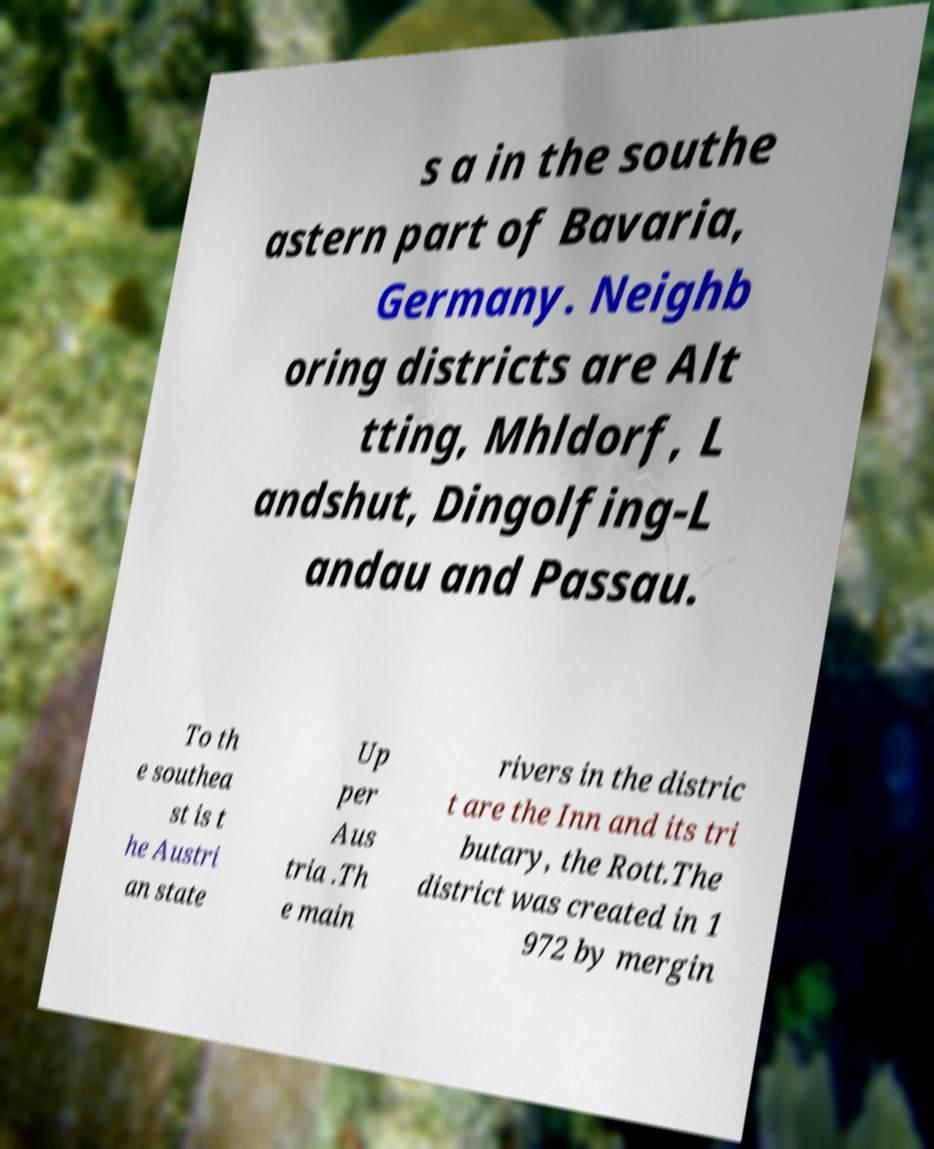Could you assist in decoding the text presented in this image and type it out clearly? s a in the southe astern part of Bavaria, Germany. Neighb oring districts are Alt tting, Mhldorf, L andshut, Dingolfing-L andau and Passau. To th e southea st is t he Austri an state Up per Aus tria .Th e main rivers in the distric t are the Inn and its tri butary, the Rott.The district was created in 1 972 by mergin 